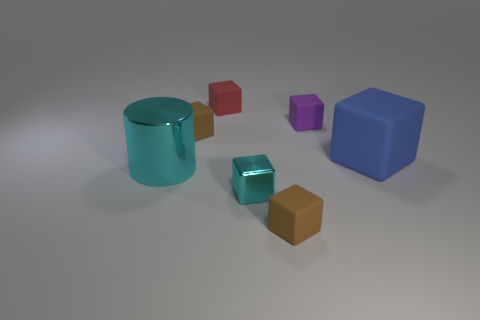Subtract all cyan cubes. How many cubes are left? 5 Subtract all blue blocks. How many blocks are left? 5 Subtract all green cubes. Subtract all gray cylinders. How many cubes are left? 6 Add 3 red rubber blocks. How many objects exist? 10 Subtract all cubes. How many objects are left? 1 Subtract 1 purple cubes. How many objects are left? 6 Subtract all rubber objects. Subtract all large cyan shiny cylinders. How many objects are left? 1 Add 2 large blocks. How many large blocks are left? 3 Add 5 tiny brown matte cubes. How many tiny brown matte cubes exist? 7 